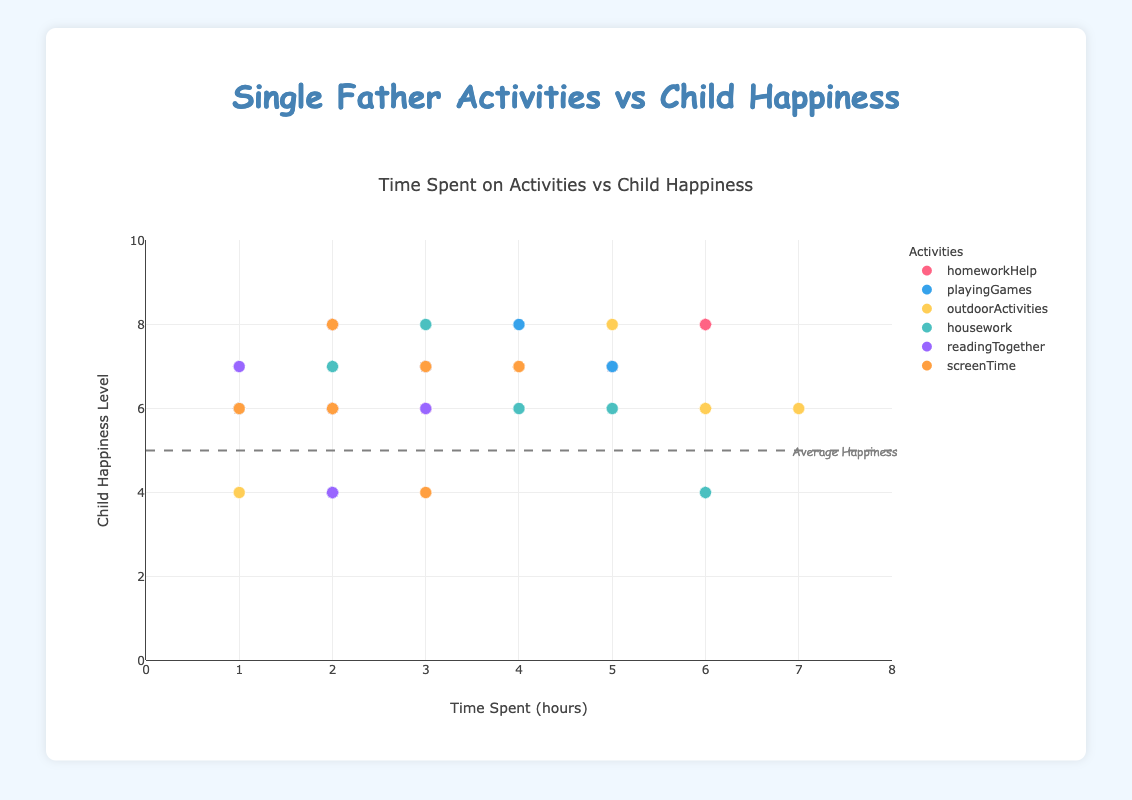What's the title of the figure? The title of the figure is prominently displayed at the top and it reads "Single Father Activities vs Child Happiness".
Answer: Single Father Activities vs Child Happiness How many activities are represented in the scatter plot? The scatter plot contains data points marked in different colors, each color representing a different activity. The legend on the right-hand side lists six activities.
Answer: Six Which father spent the most time helping with homework? By hovering over the points corresponding to "homeworkHelp" in the scatter plot, the one with the highest x-value (6 hours) is associated with John Smith.
Answer: John Smith Which activity has the highest correlation with child happiness? By observing the trends of points in each activity category, "outdoorActivities" shows a noticeable positive correlation where higher time spent aligns with higher happiness levels.
Answer: OutdoorActivities Compare the child happiness levels between the father spending maximum time on "playingGames" vs. "housework". Michael Brown spent 5 hours on playing games, and his child's happiness level is 7. David Johnson spent 6 hours on housework, and his child's happiness level is 4. 7 is greater than 4.
Answer: PlayingGames (higher) Calculate the difference in child happiness levels for fathers spending 4 hours vs. 6 hours on "homeworkHelp". John Smith (6 hours, happiness 8) and Michael Brown (4 hours, happiness 7). The difference is 8 - 7 = 1.
Answer: 1 What activity spent by Robert Jones correlates the highest with his child's happiness? For Robert Jones, hovering over the data points shows that the highest y-value (6) corresponds to 6 hours on outdoor activities.
Answer: OutdoorActivities Is there any activity where all fathers spent less than 5 hours? By hovering over the points for each activity, "readingTogether" has only points with time values 3, 2, and 1 hours, all below 5 hours.
Answer: ReadingTogether Which father’s child has the lowest happiness level and what activity did he spend the most time on? David Johnson’s child has the lowest happiness level of 4. Hovering over the respective point reveals he spent the most time (6 hours) on housework.
Answer: David Johnson, Housework What's the average happiness level of the fathers who spent more than 3 hours on "screenTime"? William Garcia (4 hours, happiness 7) and Michael Brown (3 hours, happiness 7). Average: (7 + 7) / 2 = 7.
Answer: 7 